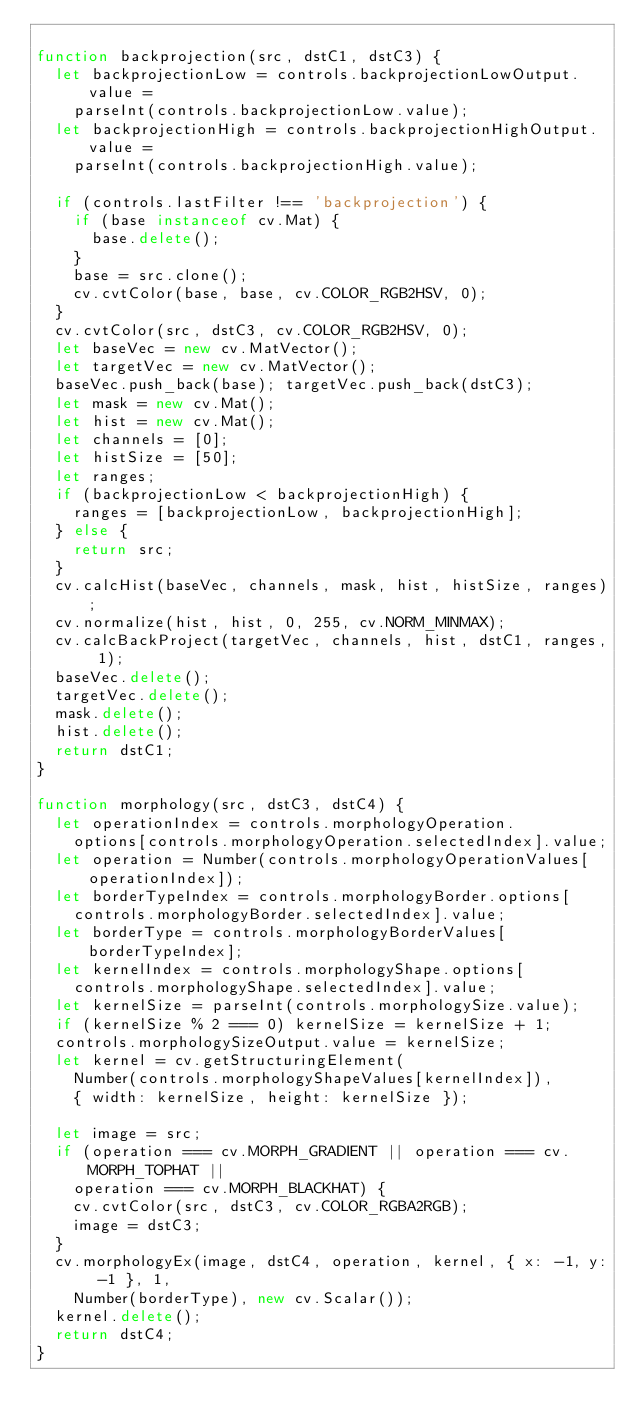Convert code to text. <code><loc_0><loc_0><loc_500><loc_500><_JavaScript_>
function backprojection(src, dstC1, dstC3) {
  let backprojectionLow = controls.backprojectionLowOutput.value =
    parseInt(controls.backprojectionLow.value);
  let backprojectionHigh = controls.backprojectionHighOutput.value =
    parseInt(controls.backprojectionHigh.value);

  if (controls.lastFilter !== 'backprojection') {
    if (base instanceof cv.Mat) {
      base.delete();
    }
    base = src.clone();
    cv.cvtColor(base, base, cv.COLOR_RGB2HSV, 0);
  }
  cv.cvtColor(src, dstC3, cv.COLOR_RGB2HSV, 0);
  let baseVec = new cv.MatVector();
  let targetVec = new cv.MatVector();
  baseVec.push_back(base); targetVec.push_back(dstC3);
  let mask = new cv.Mat();
  let hist = new cv.Mat();
  let channels = [0];
  let histSize = [50];
  let ranges;
  if (backprojectionLow < backprojectionHigh) {
    ranges = [backprojectionLow, backprojectionHigh];
  } else {
    return src;
  }
  cv.calcHist(baseVec, channels, mask, hist, histSize, ranges);
  cv.normalize(hist, hist, 0, 255, cv.NORM_MINMAX);
  cv.calcBackProject(targetVec, channels, hist, dstC1, ranges, 1);
  baseVec.delete();
  targetVec.delete();
  mask.delete();
  hist.delete();
  return dstC1;
}

function morphology(src, dstC3, dstC4) {
  let operationIndex = controls.morphologyOperation.
    options[controls.morphologyOperation.selectedIndex].value;
  let operation = Number(controls.morphologyOperationValues[operationIndex]);
  let borderTypeIndex = controls.morphologyBorder.options[
    controls.morphologyBorder.selectedIndex].value;
  let borderType = controls.morphologyBorderValues[borderTypeIndex];
  let kernelIndex = controls.morphologyShape.options[
    controls.morphologyShape.selectedIndex].value;
  let kernelSize = parseInt(controls.morphologySize.value);
  if (kernelSize % 2 === 0) kernelSize = kernelSize + 1;
  controls.morphologySizeOutput.value = kernelSize;
  let kernel = cv.getStructuringElement(
    Number(controls.morphologyShapeValues[kernelIndex]),
    { width: kernelSize, height: kernelSize });

  let image = src;
  if (operation === cv.MORPH_GRADIENT || operation === cv.MORPH_TOPHAT ||
    operation === cv.MORPH_BLACKHAT) {
    cv.cvtColor(src, dstC3, cv.COLOR_RGBA2RGB);
    image = dstC3;
  }
  cv.morphologyEx(image, dstC4, operation, kernel, { x: -1, y: -1 }, 1,
    Number(borderType), new cv.Scalar());
  kernel.delete();
  return dstC4;
}
</code> 